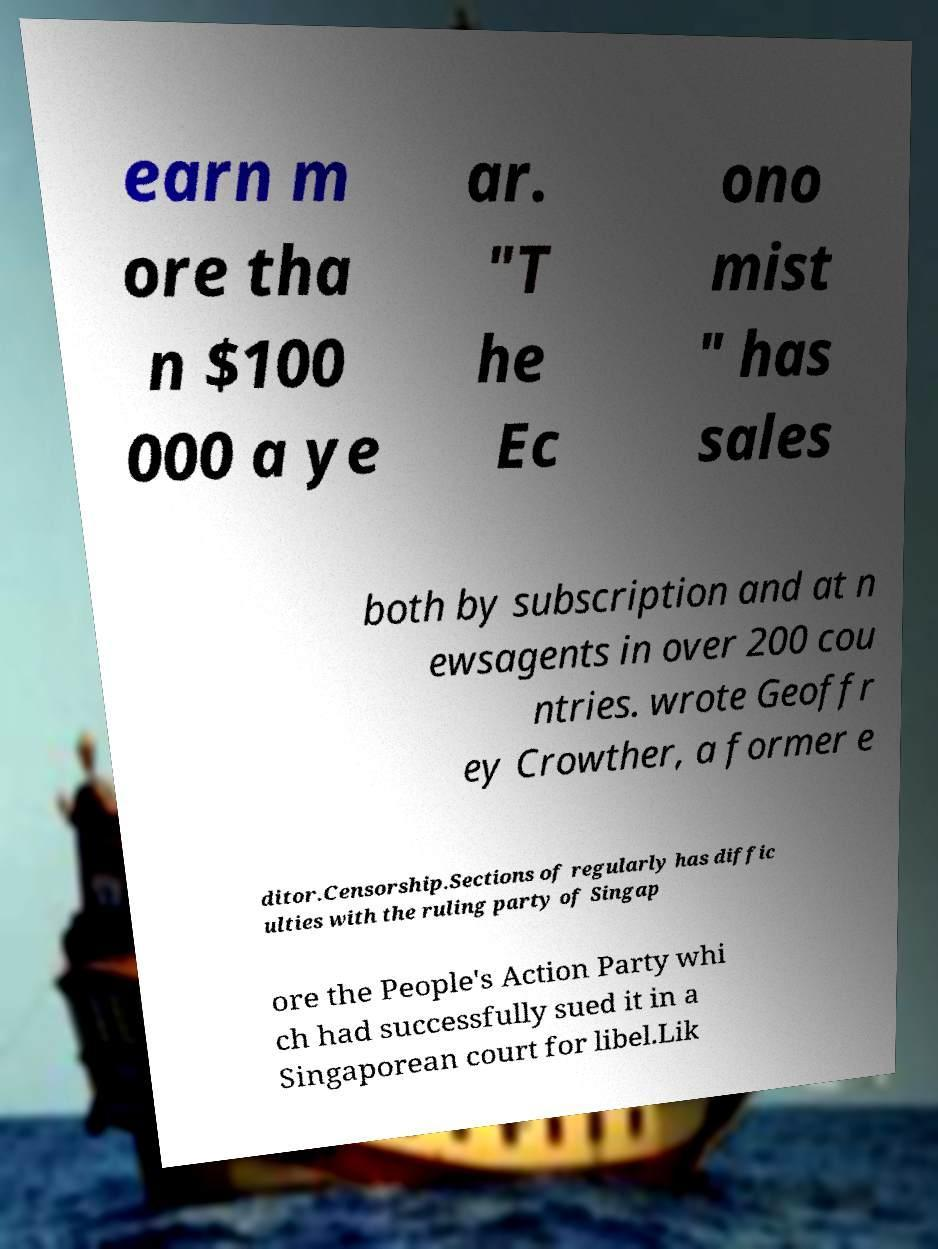Could you extract and type out the text from this image? earn m ore tha n $100 000 a ye ar. "T he Ec ono mist " has sales both by subscription and at n ewsagents in over 200 cou ntries. wrote Geoffr ey Crowther, a former e ditor.Censorship.Sections of regularly has diffic ulties with the ruling party of Singap ore the People's Action Party whi ch had successfully sued it in a Singaporean court for libel.Lik 